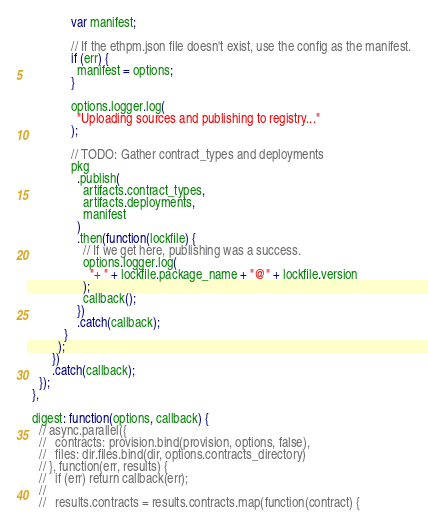Convert code to text. <code><loc_0><loc_0><loc_500><loc_500><_JavaScript_>              var manifest;

              // If the ethpm.json file doesn't exist, use the config as the manifest.
              if (err) {
                manifest = options;
              }

              options.logger.log(
                "Uploading sources and publishing to registry..."
              );

              // TODO: Gather contract_types and deployments
              pkg
                .publish(
                  artifacts.contract_types,
                  artifacts.deployments,
                  manifest
                )
                .then(function(lockfile) {
                  // If we get here, publishing was a success.
                  options.logger.log(
                    "+ " + lockfile.package_name + "@" + lockfile.version
                  );
                  callback();
                })
                .catch(callback);
            }
          );
        })
        .catch(callback);
    });
  },

  digest: function(options, callback) {
    // async.parallel({
    //   contracts: provision.bind(provision, options, false),
    //   files: dir.files.bind(dir, options.contracts_directory)
    // }, function(err, results) {
    //   if (err) return callback(err);
    //
    //   results.contracts = results.contracts.map(function(contract) {</code> 